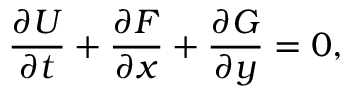Convert formula to latex. <formula><loc_0><loc_0><loc_500><loc_500>\frac { \partial U } { \partial t } + \frac { \partial F } { \partial x } + \frac { \partial G } { \partial y } = 0 ,</formula> 